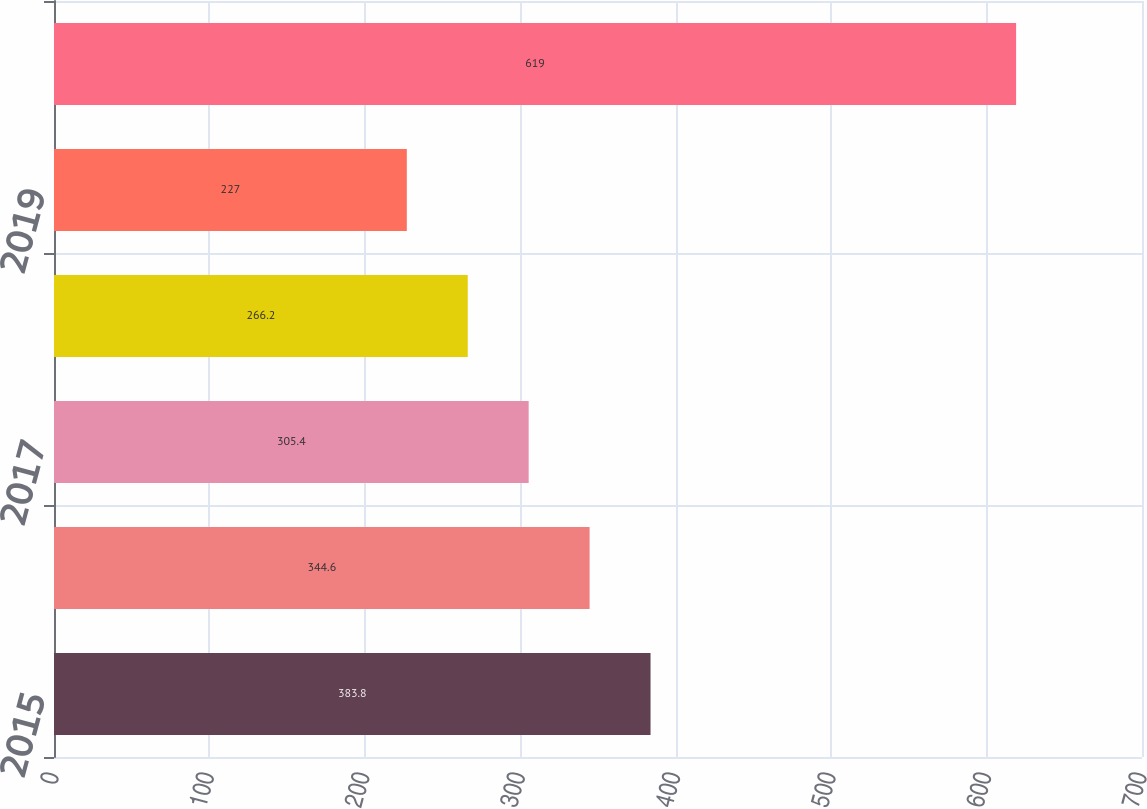Convert chart to OTSL. <chart><loc_0><loc_0><loc_500><loc_500><bar_chart><fcel>2015<fcel>2016<fcel>2017<fcel>2018<fcel>2019<fcel>Thereafter<nl><fcel>383.8<fcel>344.6<fcel>305.4<fcel>266.2<fcel>227<fcel>619<nl></chart> 